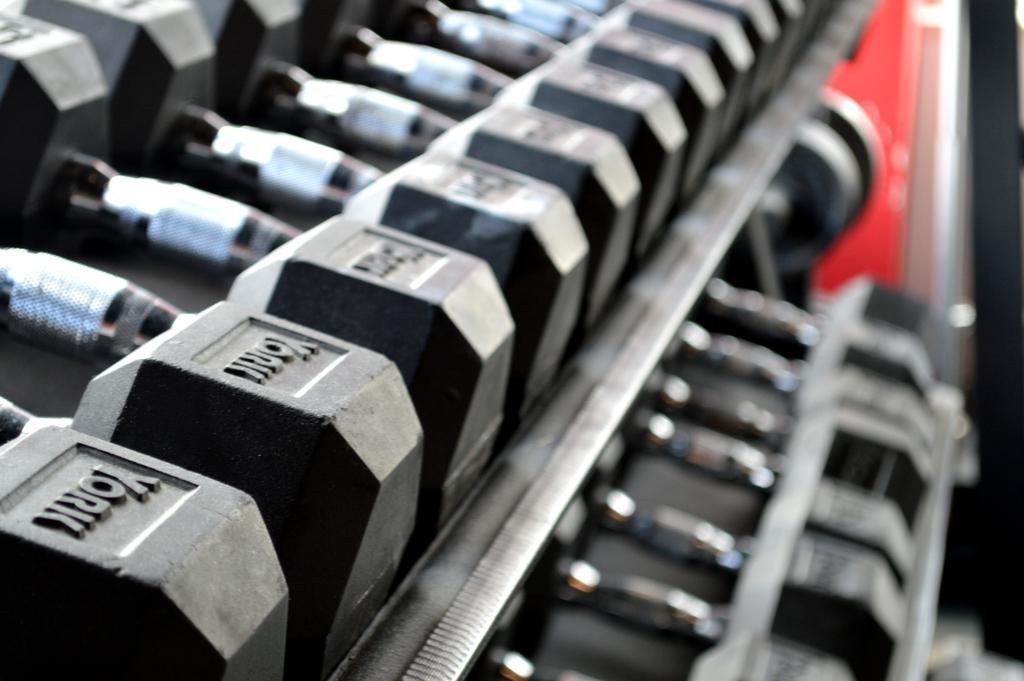What type of equipment is visible in the image? There are dumbbells in the image. How are the dumbbells arranged? The dumbbells are arranged in an order. Can you describe the background of the image? The background of the image appears blurry. What type of swing can be seen in the image? There is no swing present in the image; it features dumbbells arranged in an order. What sense is being stimulated by the dumbbells in the image? The image does not depict any sensory stimulation; it simply shows dumbbells arranged in an order. 